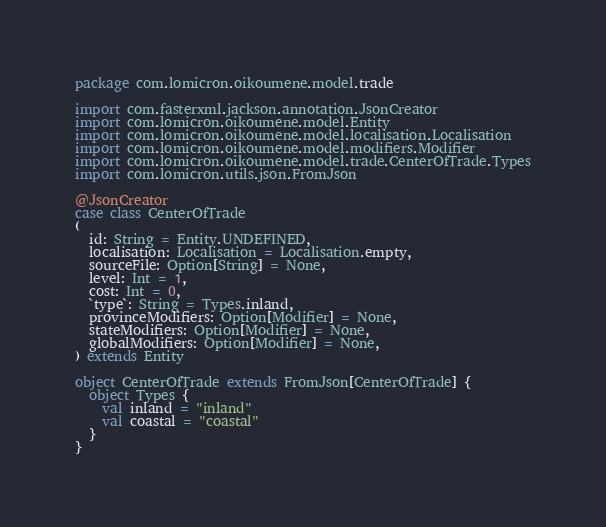<code> <loc_0><loc_0><loc_500><loc_500><_Scala_>package com.lomicron.oikoumene.model.trade

import com.fasterxml.jackson.annotation.JsonCreator
import com.lomicron.oikoumene.model.Entity
import com.lomicron.oikoumene.model.localisation.Localisation
import com.lomicron.oikoumene.model.modifiers.Modifier
import com.lomicron.oikoumene.model.trade.CenterOfTrade.Types
import com.lomicron.utils.json.FromJson

@JsonCreator
case class CenterOfTrade
(
  id: String = Entity.UNDEFINED,
  localisation: Localisation = Localisation.empty,
  sourceFile: Option[String] = None,
  level: Int = 1,
  cost: Int = 0,
  `type`: String = Types.inland,
  provinceModifiers: Option[Modifier] = None,
  stateModifiers: Option[Modifier] = None,
  globalModifiers: Option[Modifier] = None,
) extends Entity

object CenterOfTrade extends FromJson[CenterOfTrade] {
  object Types {
    val inland = "inland"
    val coastal = "coastal"
  }
}
</code> 